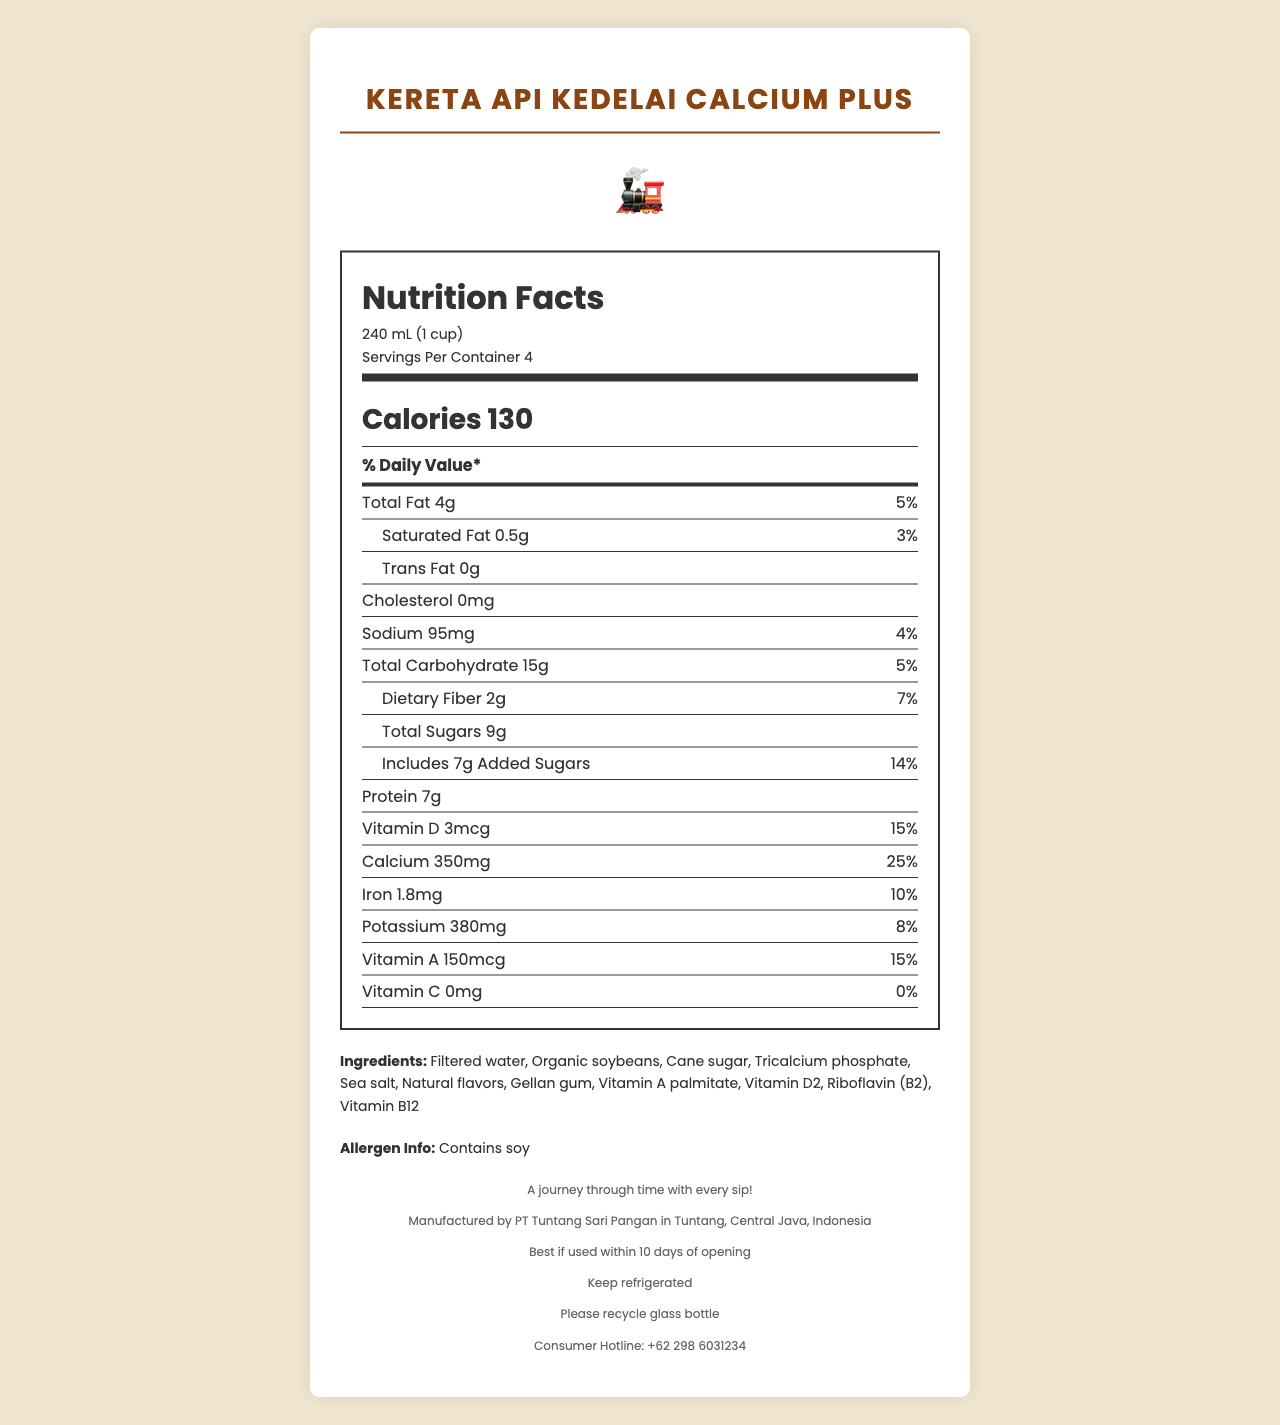what is the serving size for the product? The serving size is clearly stated at the top of the Nutrition Facts section.
Answer: 240 mL (1 cup) how many servings are in one container? The number of servings per container is mentioned just below the serving size in the Nutrition Facts section.
Answer: 4 what is the calorie content in one serving? The calorie content per serving is prominently displayed in the middle of the Nutrition Facts section.
Answer: 130 calories how much calcium is in one serving of the product? The amount of calcium can be found in the list of nutrients and is stated as 350 mg.
Answer: 350 mg does the product contain any cholesterol? The nutrient list shows that cholesterol is 0 mg.
Answer: No what is the percentage of daily value for iron? The percentage of daily value for iron is listed as 10% in the nutrients section of the Nutrition Facts.
Answer: 10% which ingredient is NOT listed in the product? A. Cane sugar B. Organic soybeans C. High fructose corn syrup D. Sea salt High fructose corn syrup is not listed in the ingredients; the others are.
Answer: C how much added sugars are included in each serving? A. 6g B. 7g C. 8g D. 9g The amount of added sugars included is 7g as indicated in the Nutrition Facts section.
Answer: B is the bottle recyclable? The recycling information at the bottom of the document states that the glass bottle should be recycled.
Answer: Yes summarize the main idea of this document. The summary includes key information about the product's nutritional content, packaging, manufacturer, and storage instructions.
Answer: The document provides detailed nutrition information about "Kereta Api Kedelai Calcium Plus," a calcium-rich soy milk drink, packaged in a nostalgic railway-themed bottle. It includes serving size, calories, nutrient amounts, and ingredient details. The product is manufactured by PT Tuntang Sari Pangan in Tuntang, Central Java, Indonesia, with emphasis on its nostalgic packaging inspired by the Ambarawa Railway Museum. It also specifies allergen information and storage instructions. how many grams of dietary fiber are in each serving? The amount of dietary fiber is listed as 2g in the nutrients section.
Answer: 2g what is the consumer hotline number for this product? The consumer hotline number is stated at the bottom of the document.
Answer: +62 298 6031234 can the document tell us the price of the product? The document does not include any information about the product's price.
Answer: Cannot be determined how many grams of protein does the soy milk have per serving? The amount of protein is listed as 7g in the nutrients section.
Answer: 7g identify the manufacturer and location of production for this soy milk. The footer of the document specifies the manufacturer and production location.
Answer: PT Tuntang Sari Pangan, Tuntang, Central Java, Indonesia does the product contain any vitamins or minerals? The Nutrition Facts section lists several vitamins and minerals such as Vitamin D, Calcium, Iron, Potassium, and Vitamin A.
Answer: Yes what is the product's tagline? The tagline is included in the footer of the document.
Answer: A journey through time with every sip! when should the product be used by after opening? The expiration information states this at the bottom of the document.
Answer: Best if used within 10 days of opening 